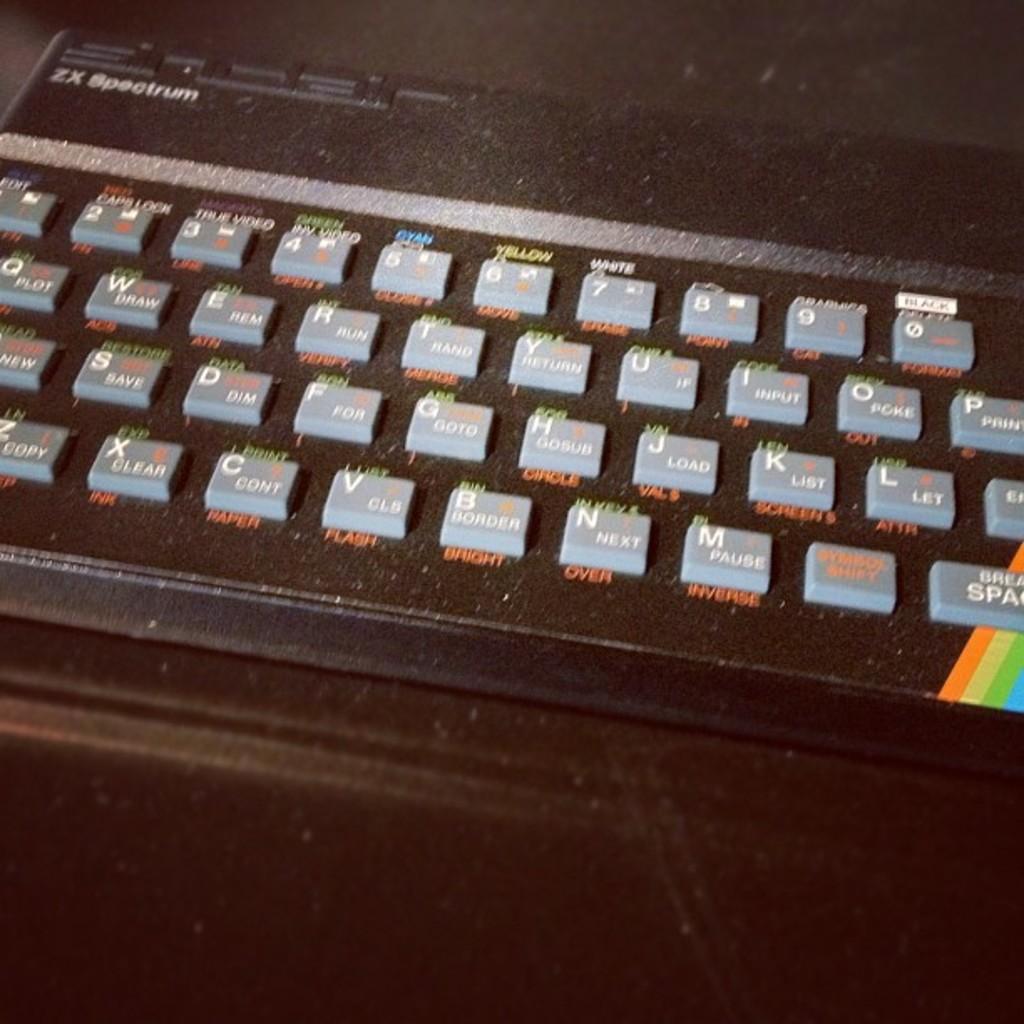What is the model of the keyboard?
Ensure brevity in your answer.  Zx spectrum. 